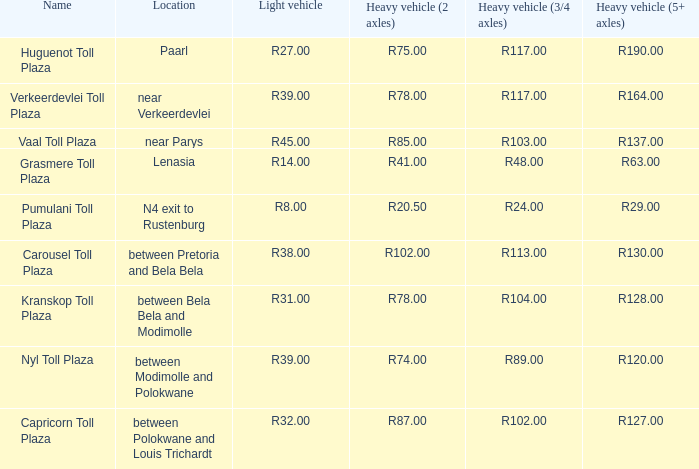What is the toll for light vehicles at the plaza between bela bela and modimolle? R31.00. 